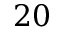Convert formula to latex. <formula><loc_0><loc_0><loc_500><loc_500>2 0</formula> 